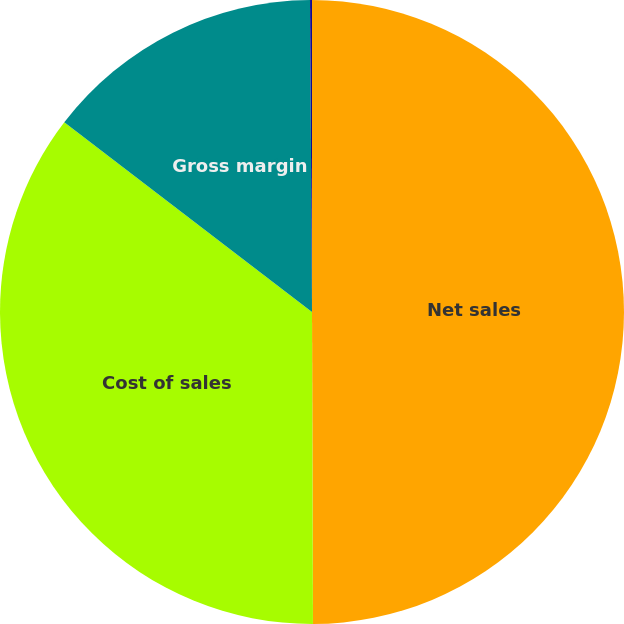Convert chart. <chart><loc_0><loc_0><loc_500><loc_500><pie_chart><fcel>Net sales<fcel>Cost of sales<fcel>Gross margin<fcel>Gross margin percentage<nl><fcel>49.95%<fcel>35.45%<fcel>14.5%<fcel>0.1%<nl></chart> 